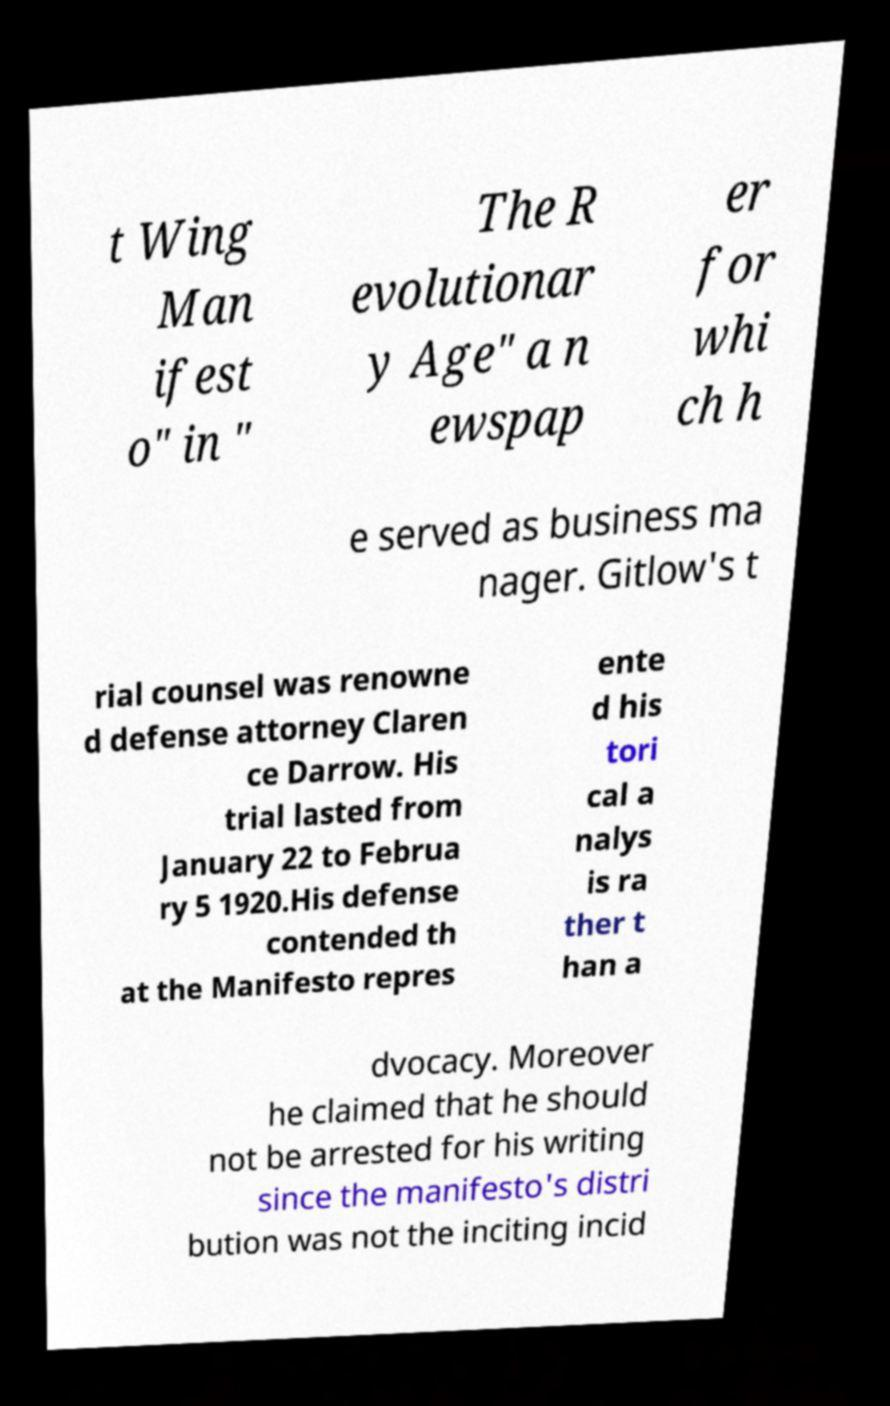There's text embedded in this image that I need extracted. Can you transcribe it verbatim? t Wing Man ifest o" in " The R evolutionar y Age" a n ewspap er for whi ch h e served as business ma nager. Gitlow's t rial counsel was renowne d defense attorney Claren ce Darrow. His trial lasted from January 22 to Februa ry 5 1920.His defense contended th at the Manifesto repres ente d his tori cal a nalys is ra ther t han a dvocacy. Moreover he claimed that he should not be arrested for his writing since the manifesto's distri bution was not the inciting incid 